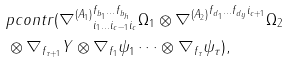<formula> <loc_0><loc_0><loc_500><loc_500>& p c o n t r ( { \nabla ^ { ( A _ { 1 } ) } } ^ { f _ { b _ { 1 } } \dots f _ { b _ { h } } } _ { i _ { 1 } \dots i _ { c - 1 } i _ { c } } \Omega _ { 1 } \otimes { \nabla ^ { ( A _ { 2 } ) } } ^ { f _ { d _ { 1 } } \dots f _ { d _ { y } } i _ { c + 1 } } \Omega _ { 2 } \\ & \otimes \nabla _ { f _ { \tau + 1 } } Y \otimes \nabla _ { f _ { 1 } } \psi _ { 1 } \dots \otimes \nabla _ { f _ { \tau } } \psi _ { \tau } ) ,</formula> 